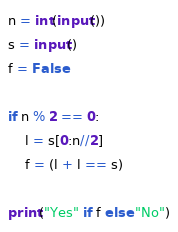<code> <loc_0><loc_0><loc_500><loc_500><_Python_>n = int(input())
s = input()
f = False

if n % 2 == 0:
	l = s[0:n//2]
	f = (l + l == s)

print("Yes" if f else "No")
</code> 